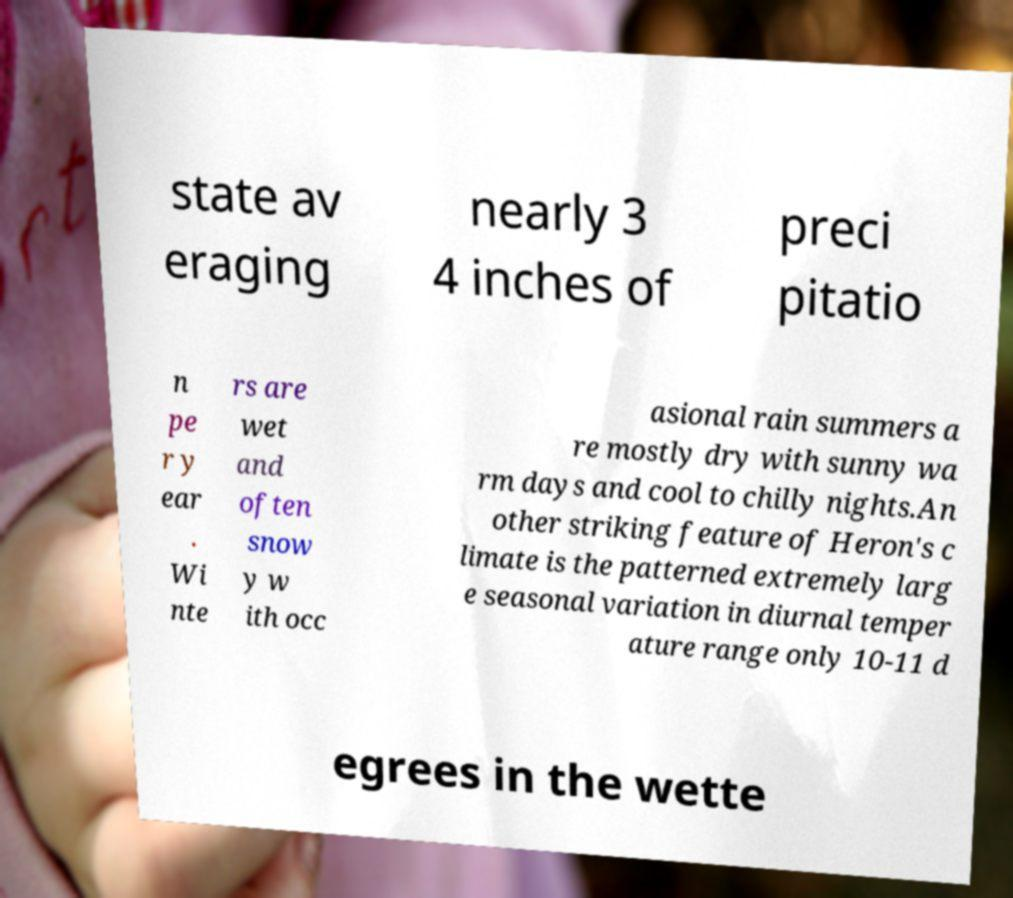Could you extract and type out the text from this image? state av eraging nearly 3 4 inches of preci pitatio n pe r y ear . Wi nte rs are wet and often snow y w ith occ asional rain summers a re mostly dry with sunny wa rm days and cool to chilly nights.An other striking feature of Heron's c limate is the patterned extremely larg e seasonal variation in diurnal temper ature range only 10-11 d egrees in the wette 